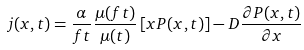Convert formula to latex. <formula><loc_0><loc_0><loc_500><loc_500>j ( x , t ) = \frac { \alpha } { f t } \frac { \mu ( f t ) } { \mu ( t ) } \left [ x P ( x , t ) \right ] - D \frac { \partial P ( x , t ) } { \partial x }</formula> 